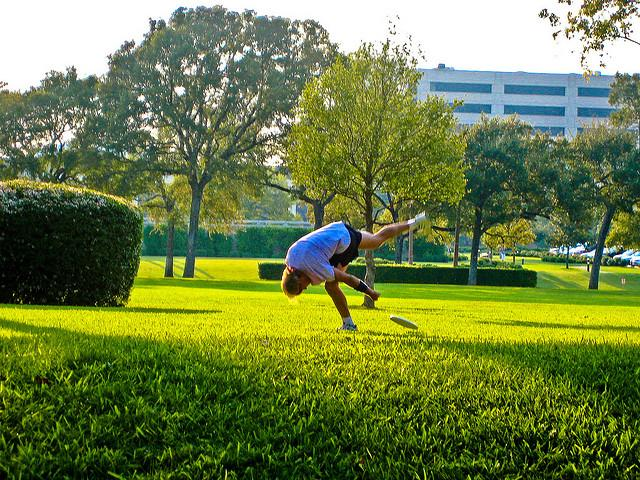What is the possible danger faced by the man? Please explain your reasoning. concussion. A man is jumping and flipping over and his head is down near the ground. 